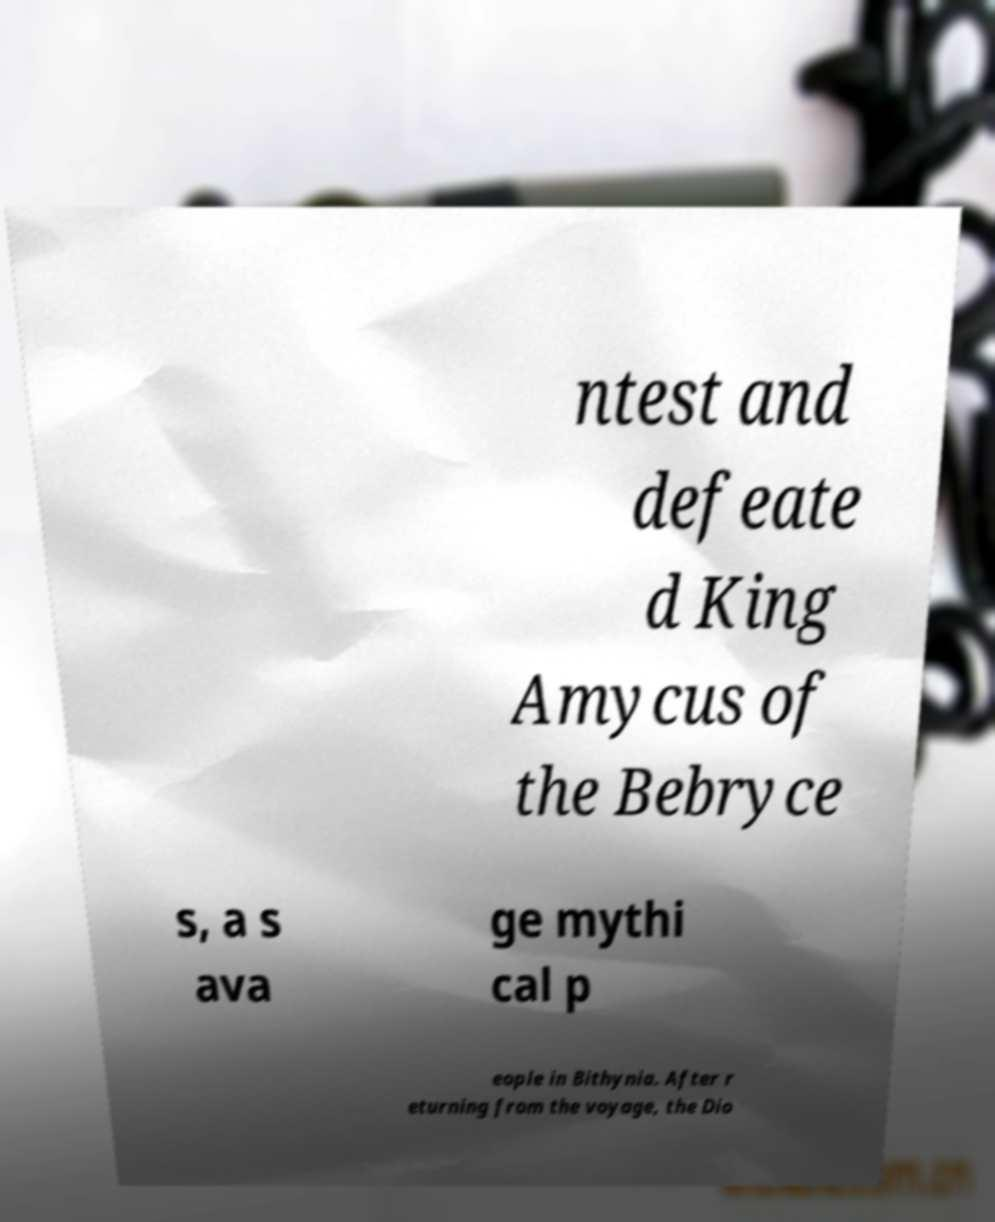Can you accurately transcribe the text from the provided image for me? ntest and defeate d King Amycus of the Bebryce s, a s ava ge mythi cal p eople in Bithynia. After r eturning from the voyage, the Dio 